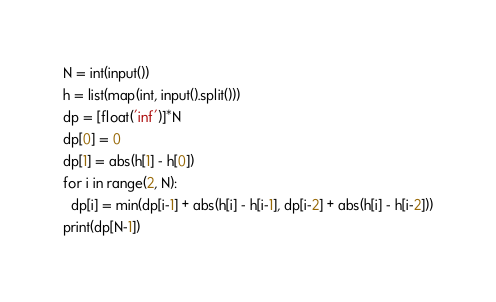<code> <loc_0><loc_0><loc_500><loc_500><_Python_>N = int(input())
h = list(map(int, input().split()))
dp = [float('inf')]*N
dp[0] = 0
dp[1] = abs(h[1] - h[0])
for i in range(2, N):
  dp[i] = min(dp[i-1] + abs(h[i] - h[i-1], dp[i-2] + abs(h[i] - h[i-2]))
print(dp[N-1])</code> 